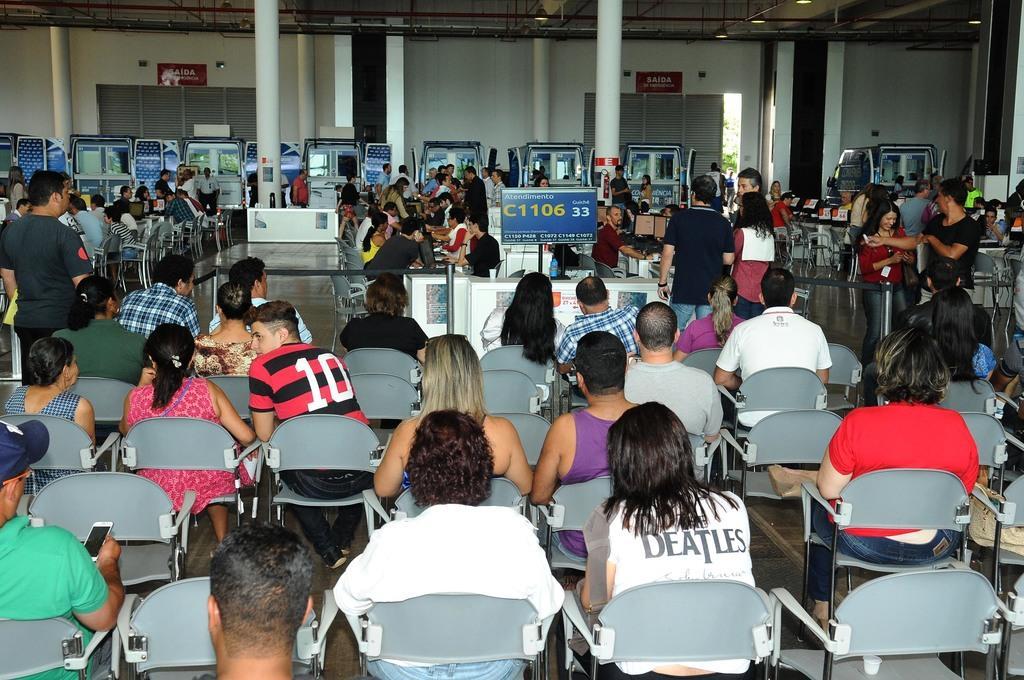Can you describe this image briefly? In this image i can see few people some are sitting and some are standing at the back ground i can see a banner,a pillow,a machine and a wall. 